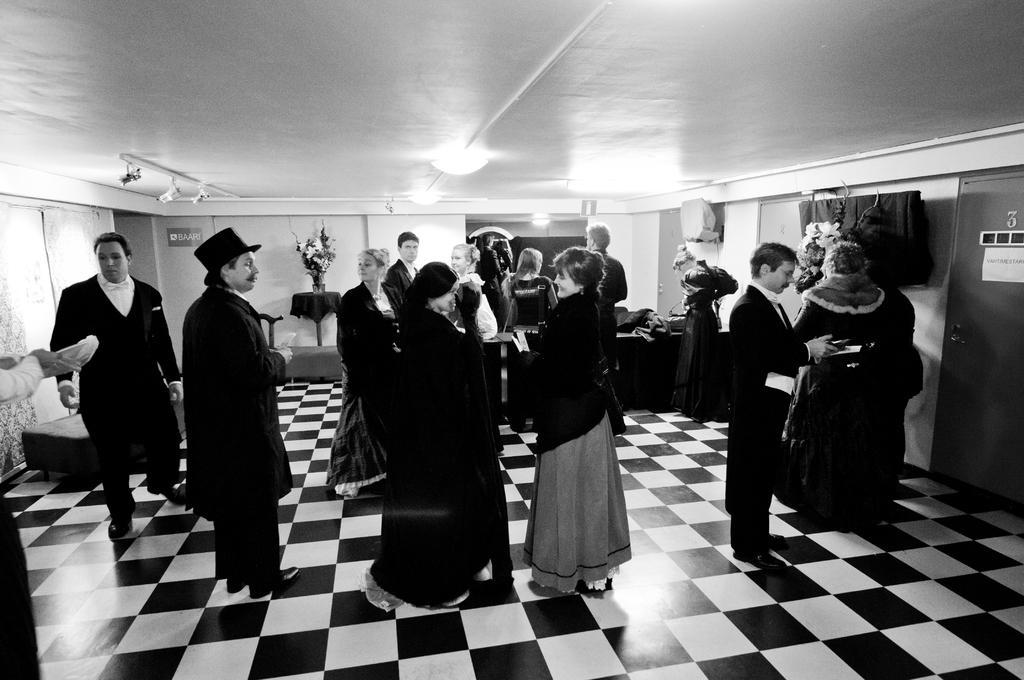Describe this image in one or two sentences. This is the picture of a room. In this image there are group of people standing. At the back there are objects on the table and there is a flower vase on the table and there is a chair and there is a board on the wall and there is text on the board. On the right side of the image there is a poster on the door and there is text on the poster and there it looks like a screen on the wall. At the top there are lights and there are pipes. At the bottom there is a floor. On the left side of the image where it looks like a curtain. 